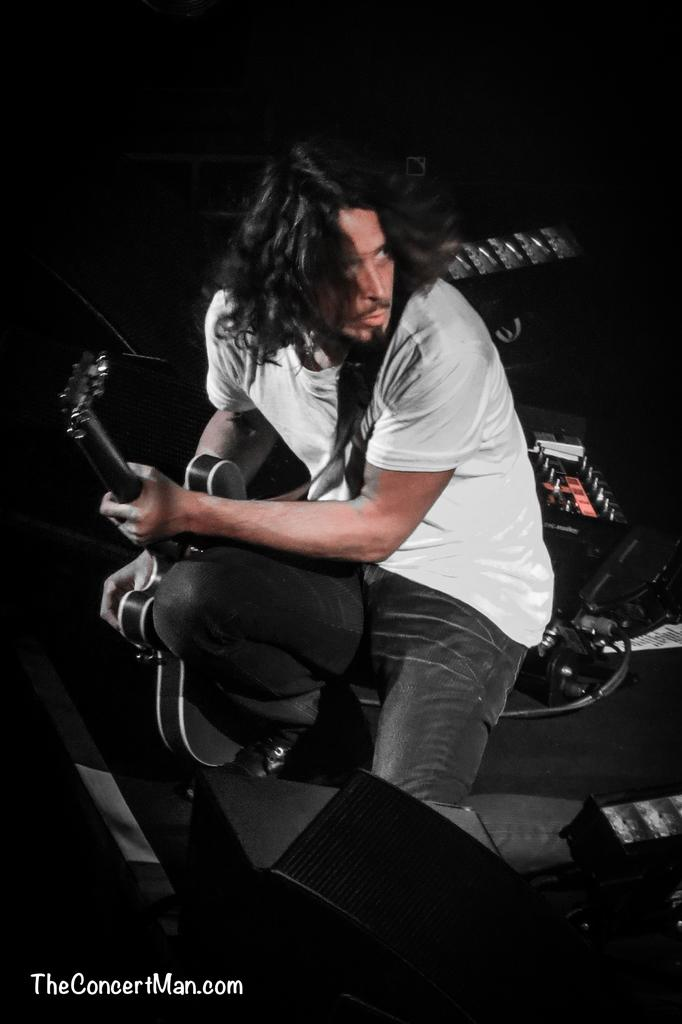What is the person in the image doing? The person is sitting in the image and holding a guitar. What might the person be engaged in based on the presence of the guitar? The person might be playing or practicing music, as they are holding a guitar. What other musical instruments can be seen in the image? There are musical instruments in the background of the image, but their specific types are not mentioned. What type of pancake is being served in the prison in the image? There is no prison or pancake present in the image; it features a person holding a guitar and musical instruments in the background. 